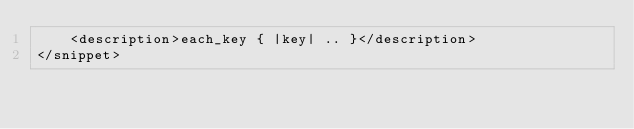Convert code to text. <code><loc_0><loc_0><loc_500><loc_500><_XML_>    <description>each_key { |key| .. }</description>
</snippet>
</code> 